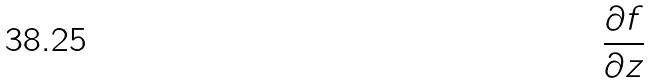<formula> <loc_0><loc_0><loc_500><loc_500>\frac { \partial f } { \partial z }</formula> 